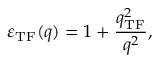<formula> <loc_0><loc_0><loc_500><loc_500>\varepsilon _ { T F } ( q ) = 1 + \frac { q _ { T F } ^ { 2 } } { q ^ { 2 } } ,</formula> 